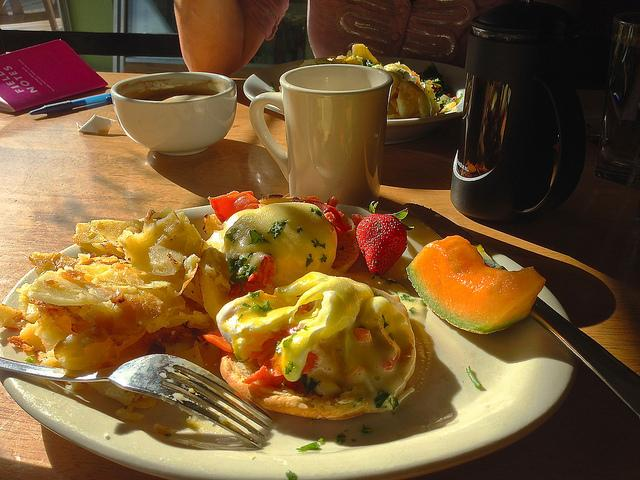What is the yellow sauce's name in the culinary world?

Choices:
A) bearnaise
B) hollandaise
C) bechamel
D) choron hollandaise 